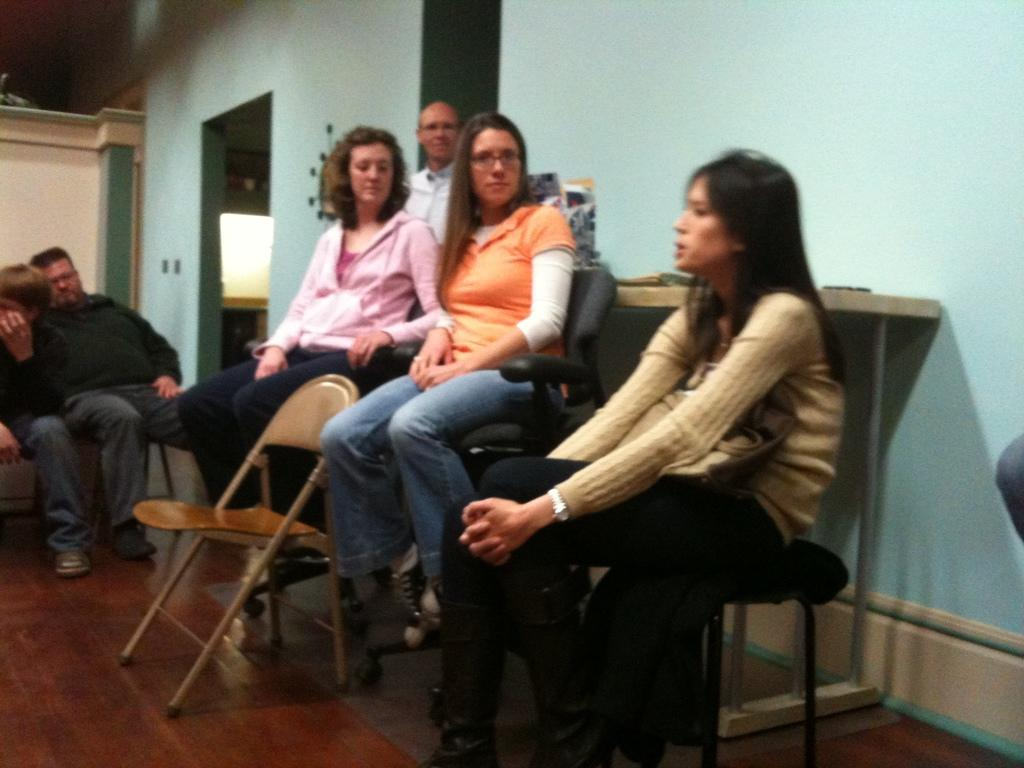How many people are in the image? There are people in the image, but the exact number is not specified. What are some of the people doing in the image? Some people are seated on chairs, while others are standing. What is the position of the chair in relation to the people? There is a chair in front of the people. What can be seen in the background of the image? There is a wall in the background of the image. Is there a squirrel wearing a vest and participating in the expansion process in the image? No, there is no squirrel, vest, or expansion process present in the image. 